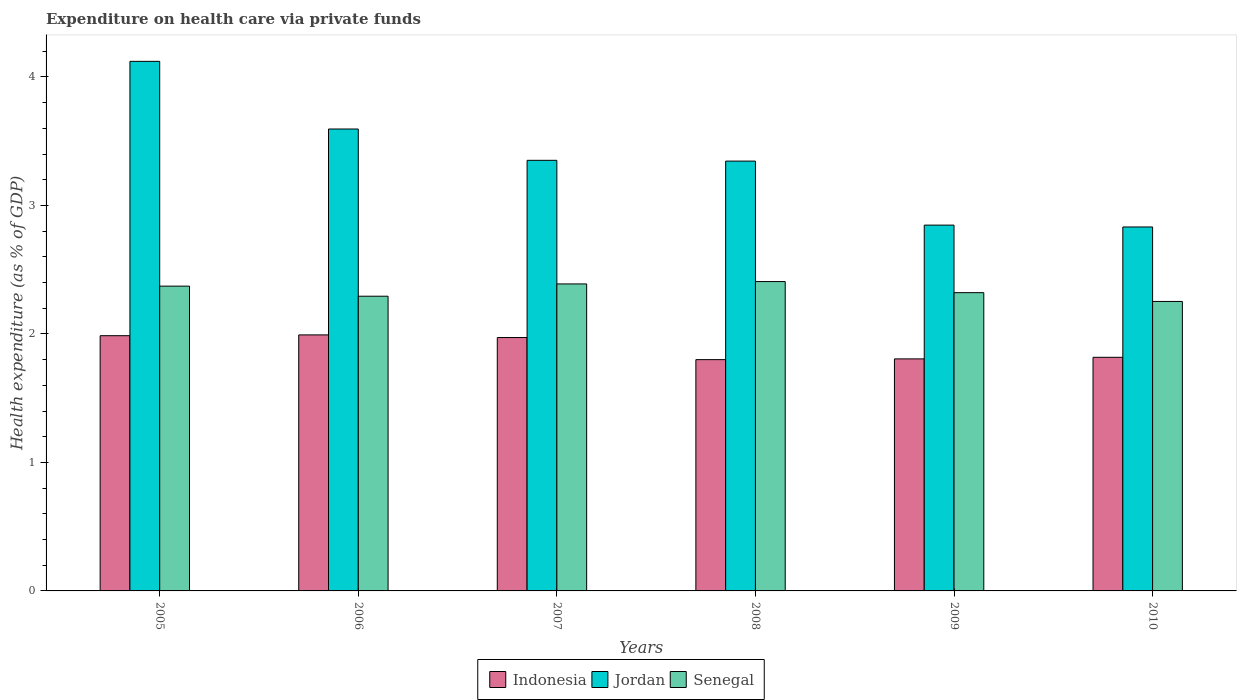Are the number of bars per tick equal to the number of legend labels?
Provide a succinct answer. Yes. Are the number of bars on each tick of the X-axis equal?
Give a very brief answer. Yes. What is the label of the 3rd group of bars from the left?
Your answer should be compact. 2007. What is the expenditure made on health care in Indonesia in 2010?
Offer a terse response. 1.82. Across all years, what is the maximum expenditure made on health care in Indonesia?
Make the answer very short. 1.99. Across all years, what is the minimum expenditure made on health care in Senegal?
Give a very brief answer. 2.25. What is the total expenditure made on health care in Indonesia in the graph?
Your answer should be very brief. 11.38. What is the difference between the expenditure made on health care in Jordan in 2008 and that in 2009?
Provide a short and direct response. 0.5. What is the difference between the expenditure made on health care in Jordan in 2007 and the expenditure made on health care in Indonesia in 2010?
Give a very brief answer. 1.53. What is the average expenditure made on health care in Senegal per year?
Provide a short and direct response. 2.34. In the year 2006, what is the difference between the expenditure made on health care in Senegal and expenditure made on health care in Jordan?
Your answer should be compact. -1.3. In how many years, is the expenditure made on health care in Senegal greater than 1.8 %?
Provide a succinct answer. 6. What is the ratio of the expenditure made on health care in Jordan in 2005 to that in 2009?
Your response must be concise. 1.45. Is the expenditure made on health care in Senegal in 2006 less than that in 2009?
Provide a succinct answer. Yes. What is the difference between the highest and the second highest expenditure made on health care in Jordan?
Offer a very short reply. 0.53. What is the difference between the highest and the lowest expenditure made on health care in Indonesia?
Offer a very short reply. 0.19. In how many years, is the expenditure made on health care in Senegal greater than the average expenditure made on health care in Senegal taken over all years?
Provide a succinct answer. 3. What does the 2nd bar from the left in 2006 represents?
Keep it short and to the point. Jordan. What does the 3rd bar from the right in 2005 represents?
Provide a short and direct response. Indonesia. Is it the case that in every year, the sum of the expenditure made on health care in Indonesia and expenditure made on health care in Senegal is greater than the expenditure made on health care in Jordan?
Give a very brief answer. Yes. How many bars are there?
Provide a succinct answer. 18. Are the values on the major ticks of Y-axis written in scientific E-notation?
Make the answer very short. No. Does the graph contain any zero values?
Provide a succinct answer. No. Where does the legend appear in the graph?
Make the answer very short. Bottom center. How many legend labels are there?
Your answer should be compact. 3. What is the title of the graph?
Provide a short and direct response. Expenditure on health care via private funds. What is the label or title of the Y-axis?
Provide a succinct answer. Health expenditure (as % of GDP). What is the Health expenditure (as % of GDP) in Indonesia in 2005?
Provide a short and direct response. 1.99. What is the Health expenditure (as % of GDP) of Jordan in 2005?
Provide a short and direct response. 4.12. What is the Health expenditure (as % of GDP) in Senegal in 2005?
Provide a short and direct response. 2.37. What is the Health expenditure (as % of GDP) in Indonesia in 2006?
Your answer should be compact. 1.99. What is the Health expenditure (as % of GDP) of Jordan in 2006?
Give a very brief answer. 3.6. What is the Health expenditure (as % of GDP) in Senegal in 2006?
Keep it short and to the point. 2.29. What is the Health expenditure (as % of GDP) of Indonesia in 2007?
Your response must be concise. 1.97. What is the Health expenditure (as % of GDP) in Jordan in 2007?
Offer a terse response. 3.35. What is the Health expenditure (as % of GDP) in Senegal in 2007?
Your answer should be compact. 2.39. What is the Health expenditure (as % of GDP) in Indonesia in 2008?
Ensure brevity in your answer.  1.8. What is the Health expenditure (as % of GDP) of Jordan in 2008?
Provide a short and direct response. 3.35. What is the Health expenditure (as % of GDP) of Senegal in 2008?
Your response must be concise. 2.41. What is the Health expenditure (as % of GDP) in Indonesia in 2009?
Offer a very short reply. 1.81. What is the Health expenditure (as % of GDP) of Jordan in 2009?
Ensure brevity in your answer.  2.85. What is the Health expenditure (as % of GDP) in Senegal in 2009?
Make the answer very short. 2.32. What is the Health expenditure (as % of GDP) of Indonesia in 2010?
Provide a short and direct response. 1.82. What is the Health expenditure (as % of GDP) of Jordan in 2010?
Offer a terse response. 2.83. What is the Health expenditure (as % of GDP) of Senegal in 2010?
Your answer should be compact. 2.25. Across all years, what is the maximum Health expenditure (as % of GDP) of Indonesia?
Keep it short and to the point. 1.99. Across all years, what is the maximum Health expenditure (as % of GDP) in Jordan?
Offer a terse response. 4.12. Across all years, what is the maximum Health expenditure (as % of GDP) in Senegal?
Offer a terse response. 2.41. Across all years, what is the minimum Health expenditure (as % of GDP) in Indonesia?
Give a very brief answer. 1.8. Across all years, what is the minimum Health expenditure (as % of GDP) of Jordan?
Your response must be concise. 2.83. Across all years, what is the minimum Health expenditure (as % of GDP) of Senegal?
Make the answer very short. 2.25. What is the total Health expenditure (as % of GDP) in Indonesia in the graph?
Your response must be concise. 11.38. What is the total Health expenditure (as % of GDP) of Jordan in the graph?
Offer a terse response. 20.09. What is the total Health expenditure (as % of GDP) of Senegal in the graph?
Offer a very short reply. 14.04. What is the difference between the Health expenditure (as % of GDP) in Indonesia in 2005 and that in 2006?
Make the answer very short. -0.01. What is the difference between the Health expenditure (as % of GDP) in Jordan in 2005 and that in 2006?
Ensure brevity in your answer.  0.53. What is the difference between the Health expenditure (as % of GDP) of Senegal in 2005 and that in 2006?
Make the answer very short. 0.08. What is the difference between the Health expenditure (as % of GDP) in Indonesia in 2005 and that in 2007?
Give a very brief answer. 0.01. What is the difference between the Health expenditure (as % of GDP) of Jordan in 2005 and that in 2007?
Your response must be concise. 0.77. What is the difference between the Health expenditure (as % of GDP) in Senegal in 2005 and that in 2007?
Give a very brief answer. -0.02. What is the difference between the Health expenditure (as % of GDP) of Indonesia in 2005 and that in 2008?
Your response must be concise. 0.19. What is the difference between the Health expenditure (as % of GDP) in Jordan in 2005 and that in 2008?
Make the answer very short. 0.78. What is the difference between the Health expenditure (as % of GDP) of Senegal in 2005 and that in 2008?
Ensure brevity in your answer.  -0.04. What is the difference between the Health expenditure (as % of GDP) of Indonesia in 2005 and that in 2009?
Provide a short and direct response. 0.18. What is the difference between the Health expenditure (as % of GDP) in Jordan in 2005 and that in 2009?
Your answer should be very brief. 1.27. What is the difference between the Health expenditure (as % of GDP) in Senegal in 2005 and that in 2009?
Offer a very short reply. 0.05. What is the difference between the Health expenditure (as % of GDP) of Indonesia in 2005 and that in 2010?
Give a very brief answer. 0.17. What is the difference between the Health expenditure (as % of GDP) in Jordan in 2005 and that in 2010?
Your answer should be very brief. 1.29. What is the difference between the Health expenditure (as % of GDP) in Senegal in 2005 and that in 2010?
Offer a terse response. 0.12. What is the difference between the Health expenditure (as % of GDP) of Indonesia in 2006 and that in 2007?
Keep it short and to the point. 0.02. What is the difference between the Health expenditure (as % of GDP) of Jordan in 2006 and that in 2007?
Offer a terse response. 0.24. What is the difference between the Health expenditure (as % of GDP) in Senegal in 2006 and that in 2007?
Provide a short and direct response. -0.1. What is the difference between the Health expenditure (as % of GDP) in Indonesia in 2006 and that in 2008?
Keep it short and to the point. 0.19. What is the difference between the Health expenditure (as % of GDP) of Jordan in 2006 and that in 2008?
Your answer should be very brief. 0.25. What is the difference between the Health expenditure (as % of GDP) of Senegal in 2006 and that in 2008?
Make the answer very short. -0.11. What is the difference between the Health expenditure (as % of GDP) in Indonesia in 2006 and that in 2009?
Provide a short and direct response. 0.19. What is the difference between the Health expenditure (as % of GDP) of Jordan in 2006 and that in 2009?
Make the answer very short. 0.75. What is the difference between the Health expenditure (as % of GDP) of Senegal in 2006 and that in 2009?
Your answer should be compact. -0.03. What is the difference between the Health expenditure (as % of GDP) in Indonesia in 2006 and that in 2010?
Make the answer very short. 0.17. What is the difference between the Health expenditure (as % of GDP) in Jordan in 2006 and that in 2010?
Your answer should be very brief. 0.76. What is the difference between the Health expenditure (as % of GDP) of Senegal in 2006 and that in 2010?
Your answer should be very brief. 0.04. What is the difference between the Health expenditure (as % of GDP) of Indonesia in 2007 and that in 2008?
Your response must be concise. 0.17. What is the difference between the Health expenditure (as % of GDP) in Jordan in 2007 and that in 2008?
Make the answer very short. 0.01. What is the difference between the Health expenditure (as % of GDP) of Senegal in 2007 and that in 2008?
Make the answer very short. -0.02. What is the difference between the Health expenditure (as % of GDP) of Indonesia in 2007 and that in 2009?
Provide a short and direct response. 0.17. What is the difference between the Health expenditure (as % of GDP) in Jordan in 2007 and that in 2009?
Your answer should be very brief. 0.5. What is the difference between the Health expenditure (as % of GDP) in Senegal in 2007 and that in 2009?
Your answer should be compact. 0.07. What is the difference between the Health expenditure (as % of GDP) in Indonesia in 2007 and that in 2010?
Your answer should be very brief. 0.15. What is the difference between the Health expenditure (as % of GDP) of Jordan in 2007 and that in 2010?
Offer a terse response. 0.52. What is the difference between the Health expenditure (as % of GDP) of Senegal in 2007 and that in 2010?
Offer a terse response. 0.14. What is the difference between the Health expenditure (as % of GDP) of Indonesia in 2008 and that in 2009?
Offer a terse response. -0.01. What is the difference between the Health expenditure (as % of GDP) in Jordan in 2008 and that in 2009?
Your answer should be very brief. 0.5. What is the difference between the Health expenditure (as % of GDP) in Senegal in 2008 and that in 2009?
Ensure brevity in your answer.  0.09. What is the difference between the Health expenditure (as % of GDP) in Indonesia in 2008 and that in 2010?
Your response must be concise. -0.02. What is the difference between the Health expenditure (as % of GDP) in Jordan in 2008 and that in 2010?
Your answer should be compact. 0.51. What is the difference between the Health expenditure (as % of GDP) of Senegal in 2008 and that in 2010?
Offer a terse response. 0.15. What is the difference between the Health expenditure (as % of GDP) of Indonesia in 2009 and that in 2010?
Keep it short and to the point. -0.01. What is the difference between the Health expenditure (as % of GDP) in Jordan in 2009 and that in 2010?
Make the answer very short. 0.01. What is the difference between the Health expenditure (as % of GDP) in Senegal in 2009 and that in 2010?
Your answer should be compact. 0.07. What is the difference between the Health expenditure (as % of GDP) in Indonesia in 2005 and the Health expenditure (as % of GDP) in Jordan in 2006?
Your answer should be compact. -1.61. What is the difference between the Health expenditure (as % of GDP) of Indonesia in 2005 and the Health expenditure (as % of GDP) of Senegal in 2006?
Your answer should be compact. -0.31. What is the difference between the Health expenditure (as % of GDP) in Jordan in 2005 and the Health expenditure (as % of GDP) in Senegal in 2006?
Offer a very short reply. 1.83. What is the difference between the Health expenditure (as % of GDP) of Indonesia in 2005 and the Health expenditure (as % of GDP) of Jordan in 2007?
Keep it short and to the point. -1.36. What is the difference between the Health expenditure (as % of GDP) of Indonesia in 2005 and the Health expenditure (as % of GDP) of Senegal in 2007?
Your answer should be compact. -0.4. What is the difference between the Health expenditure (as % of GDP) in Jordan in 2005 and the Health expenditure (as % of GDP) in Senegal in 2007?
Provide a short and direct response. 1.73. What is the difference between the Health expenditure (as % of GDP) in Indonesia in 2005 and the Health expenditure (as % of GDP) in Jordan in 2008?
Give a very brief answer. -1.36. What is the difference between the Health expenditure (as % of GDP) in Indonesia in 2005 and the Health expenditure (as % of GDP) in Senegal in 2008?
Provide a succinct answer. -0.42. What is the difference between the Health expenditure (as % of GDP) of Jordan in 2005 and the Health expenditure (as % of GDP) of Senegal in 2008?
Ensure brevity in your answer.  1.71. What is the difference between the Health expenditure (as % of GDP) of Indonesia in 2005 and the Health expenditure (as % of GDP) of Jordan in 2009?
Offer a terse response. -0.86. What is the difference between the Health expenditure (as % of GDP) of Indonesia in 2005 and the Health expenditure (as % of GDP) of Senegal in 2009?
Keep it short and to the point. -0.33. What is the difference between the Health expenditure (as % of GDP) of Jordan in 2005 and the Health expenditure (as % of GDP) of Senegal in 2009?
Ensure brevity in your answer.  1.8. What is the difference between the Health expenditure (as % of GDP) of Indonesia in 2005 and the Health expenditure (as % of GDP) of Jordan in 2010?
Give a very brief answer. -0.85. What is the difference between the Health expenditure (as % of GDP) of Indonesia in 2005 and the Health expenditure (as % of GDP) of Senegal in 2010?
Provide a short and direct response. -0.27. What is the difference between the Health expenditure (as % of GDP) in Jordan in 2005 and the Health expenditure (as % of GDP) in Senegal in 2010?
Give a very brief answer. 1.87. What is the difference between the Health expenditure (as % of GDP) of Indonesia in 2006 and the Health expenditure (as % of GDP) of Jordan in 2007?
Provide a short and direct response. -1.36. What is the difference between the Health expenditure (as % of GDP) in Indonesia in 2006 and the Health expenditure (as % of GDP) in Senegal in 2007?
Provide a short and direct response. -0.4. What is the difference between the Health expenditure (as % of GDP) of Jordan in 2006 and the Health expenditure (as % of GDP) of Senegal in 2007?
Provide a short and direct response. 1.21. What is the difference between the Health expenditure (as % of GDP) of Indonesia in 2006 and the Health expenditure (as % of GDP) of Jordan in 2008?
Your response must be concise. -1.35. What is the difference between the Health expenditure (as % of GDP) of Indonesia in 2006 and the Health expenditure (as % of GDP) of Senegal in 2008?
Provide a succinct answer. -0.42. What is the difference between the Health expenditure (as % of GDP) in Jordan in 2006 and the Health expenditure (as % of GDP) in Senegal in 2008?
Your answer should be very brief. 1.19. What is the difference between the Health expenditure (as % of GDP) in Indonesia in 2006 and the Health expenditure (as % of GDP) in Jordan in 2009?
Your response must be concise. -0.85. What is the difference between the Health expenditure (as % of GDP) of Indonesia in 2006 and the Health expenditure (as % of GDP) of Senegal in 2009?
Keep it short and to the point. -0.33. What is the difference between the Health expenditure (as % of GDP) in Jordan in 2006 and the Health expenditure (as % of GDP) in Senegal in 2009?
Offer a terse response. 1.27. What is the difference between the Health expenditure (as % of GDP) of Indonesia in 2006 and the Health expenditure (as % of GDP) of Jordan in 2010?
Offer a terse response. -0.84. What is the difference between the Health expenditure (as % of GDP) of Indonesia in 2006 and the Health expenditure (as % of GDP) of Senegal in 2010?
Provide a succinct answer. -0.26. What is the difference between the Health expenditure (as % of GDP) in Jordan in 2006 and the Health expenditure (as % of GDP) in Senegal in 2010?
Give a very brief answer. 1.34. What is the difference between the Health expenditure (as % of GDP) in Indonesia in 2007 and the Health expenditure (as % of GDP) in Jordan in 2008?
Offer a terse response. -1.37. What is the difference between the Health expenditure (as % of GDP) of Indonesia in 2007 and the Health expenditure (as % of GDP) of Senegal in 2008?
Make the answer very short. -0.44. What is the difference between the Health expenditure (as % of GDP) in Jordan in 2007 and the Health expenditure (as % of GDP) in Senegal in 2008?
Offer a very short reply. 0.94. What is the difference between the Health expenditure (as % of GDP) of Indonesia in 2007 and the Health expenditure (as % of GDP) of Jordan in 2009?
Your answer should be compact. -0.88. What is the difference between the Health expenditure (as % of GDP) of Indonesia in 2007 and the Health expenditure (as % of GDP) of Senegal in 2009?
Provide a short and direct response. -0.35. What is the difference between the Health expenditure (as % of GDP) in Jordan in 2007 and the Health expenditure (as % of GDP) in Senegal in 2009?
Provide a short and direct response. 1.03. What is the difference between the Health expenditure (as % of GDP) of Indonesia in 2007 and the Health expenditure (as % of GDP) of Jordan in 2010?
Offer a very short reply. -0.86. What is the difference between the Health expenditure (as % of GDP) in Indonesia in 2007 and the Health expenditure (as % of GDP) in Senegal in 2010?
Your response must be concise. -0.28. What is the difference between the Health expenditure (as % of GDP) of Jordan in 2007 and the Health expenditure (as % of GDP) of Senegal in 2010?
Make the answer very short. 1.1. What is the difference between the Health expenditure (as % of GDP) in Indonesia in 2008 and the Health expenditure (as % of GDP) in Jordan in 2009?
Ensure brevity in your answer.  -1.05. What is the difference between the Health expenditure (as % of GDP) in Indonesia in 2008 and the Health expenditure (as % of GDP) in Senegal in 2009?
Your answer should be compact. -0.52. What is the difference between the Health expenditure (as % of GDP) in Jordan in 2008 and the Health expenditure (as % of GDP) in Senegal in 2009?
Give a very brief answer. 1.02. What is the difference between the Health expenditure (as % of GDP) in Indonesia in 2008 and the Health expenditure (as % of GDP) in Jordan in 2010?
Your response must be concise. -1.03. What is the difference between the Health expenditure (as % of GDP) in Indonesia in 2008 and the Health expenditure (as % of GDP) in Senegal in 2010?
Keep it short and to the point. -0.45. What is the difference between the Health expenditure (as % of GDP) of Jordan in 2008 and the Health expenditure (as % of GDP) of Senegal in 2010?
Offer a very short reply. 1.09. What is the difference between the Health expenditure (as % of GDP) in Indonesia in 2009 and the Health expenditure (as % of GDP) in Jordan in 2010?
Offer a terse response. -1.03. What is the difference between the Health expenditure (as % of GDP) in Indonesia in 2009 and the Health expenditure (as % of GDP) in Senegal in 2010?
Make the answer very short. -0.45. What is the difference between the Health expenditure (as % of GDP) of Jordan in 2009 and the Health expenditure (as % of GDP) of Senegal in 2010?
Provide a short and direct response. 0.59. What is the average Health expenditure (as % of GDP) of Indonesia per year?
Your answer should be very brief. 1.9. What is the average Health expenditure (as % of GDP) in Jordan per year?
Your response must be concise. 3.35. What is the average Health expenditure (as % of GDP) of Senegal per year?
Provide a short and direct response. 2.34. In the year 2005, what is the difference between the Health expenditure (as % of GDP) in Indonesia and Health expenditure (as % of GDP) in Jordan?
Provide a succinct answer. -2.14. In the year 2005, what is the difference between the Health expenditure (as % of GDP) of Indonesia and Health expenditure (as % of GDP) of Senegal?
Offer a very short reply. -0.39. In the year 2005, what is the difference between the Health expenditure (as % of GDP) of Jordan and Health expenditure (as % of GDP) of Senegal?
Your response must be concise. 1.75. In the year 2006, what is the difference between the Health expenditure (as % of GDP) of Indonesia and Health expenditure (as % of GDP) of Jordan?
Provide a succinct answer. -1.6. In the year 2006, what is the difference between the Health expenditure (as % of GDP) of Indonesia and Health expenditure (as % of GDP) of Senegal?
Your answer should be compact. -0.3. In the year 2006, what is the difference between the Health expenditure (as % of GDP) of Jordan and Health expenditure (as % of GDP) of Senegal?
Give a very brief answer. 1.3. In the year 2007, what is the difference between the Health expenditure (as % of GDP) in Indonesia and Health expenditure (as % of GDP) in Jordan?
Keep it short and to the point. -1.38. In the year 2007, what is the difference between the Health expenditure (as % of GDP) of Indonesia and Health expenditure (as % of GDP) of Senegal?
Offer a terse response. -0.42. In the year 2008, what is the difference between the Health expenditure (as % of GDP) in Indonesia and Health expenditure (as % of GDP) in Jordan?
Give a very brief answer. -1.55. In the year 2008, what is the difference between the Health expenditure (as % of GDP) of Indonesia and Health expenditure (as % of GDP) of Senegal?
Give a very brief answer. -0.61. In the year 2008, what is the difference between the Health expenditure (as % of GDP) in Jordan and Health expenditure (as % of GDP) in Senegal?
Give a very brief answer. 0.94. In the year 2009, what is the difference between the Health expenditure (as % of GDP) in Indonesia and Health expenditure (as % of GDP) in Jordan?
Make the answer very short. -1.04. In the year 2009, what is the difference between the Health expenditure (as % of GDP) in Indonesia and Health expenditure (as % of GDP) in Senegal?
Offer a very short reply. -0.52. In the year 2009, what is the difference between the Health expenditure (as % of GDP) of Jordan and Health expenditure (as % of GDP) of Senegal?
Your answer should be very brief. 0.53. In the year 2010, what is the difference between the Health expenditure (as % of GDP) of Indonesia and Health expenditure (as % of GDP) of Jordan?
Offer a very short reply. -1.01. In the year 2010, what is the difference between the Health expenditure (as % of GDP) in Indonesia and Health expenditure (as % of GDP) in Senegal?
Your answer should be very brief. -0.43. In the year 2010, what is the difference between the Health expenditure (as % of GDP) in Jordan and Health expenditure (as % of GDP) in Senegal?
Keep it short and to the point. 0.58. What is the ratio of the Health expenditure (as % of GDP) of Jordan in 2005 to that in 2006?
Ensure brevity in your answer.  1.15. What is the ratio of the Health expenditure (as % of GDP) of Senegal in 2005 to that in 2006?
Make the answer very short. 1.03. What is the ratio of the Health expenditure (as % of GDP) in Indonesia in 2005 to that in 2007?
Your response must be concise. 1.01. What is the ratio of the Health expenditure (as % of GDP) in Jordan in 2005 to that in 2007?
Keep it short and to the point. 1.23. What is the ratio of the Health expenditure (as % of GDP) in Indonesia in 2005 to that in 2008?
Provide a succinct answer. 1.1. What is the ratio of the Health expenditure (as % of GDP) in Jordan in 2005 to that in 2008?
Provide a succinct answer. 1.23. What is the ratio of the Health expenditure (as % of GDP) of Indonesia in 2005 to that in 2009?
Ensure brevity in your answer.  1.1. What is the ratio of the Health expenditure (as % of GDP) of Jordan in 2005 to that in 2009?
Your answer should be compact. 1.45. What is the ratio of the Health expenditure (as % of GDP) in Senegal in 2005 to that in 2009?
Make the answer very short. 1.02. What is the ratio of the Health expenditure (as % of GDP) in Indonesia in 2005 to that in 2010?
Offer a terse response. 1.09. What is the ratio of the Health expenditure (as % of GDP) of Jordan in 2005 to that in 2010?
Give a very brief answer. 1.46. What is the ratio of the Health expenditure (as % of GDP) of Senegal in 2005 to that in 2010?
Your answer should be compact. 1.05. What is the ratio of the Health expenditure (as % of GDP) in Indonesia in 2006 to that in 2007?
Your response must be concise. 1.01. What is the ratio of the Health expenditure (as % of GDP) of Jordan in 2006 to that in 2007?
Your answer should be compact. 1.07. What is the ratio of the Health expenditure (as % of GDP) of Indonesia in 2006 to that in 2008?
Give a very brief answer. 1.11. What is the ratio of the Health expenditure (as % of GDP) in Jordan in 2006 to that in 2008?
Offer a very short reply. 1.07. What is the ratio of the Health expenditure (as % of GDP) of Senegal in 2006 to that in 2008?
Make the answer very short. 0.95. What is the ratio of the Health expenditure (as % of GDP) in Indonesia in 2006 to that in 2009?
Keep it short and to the point. 1.1. What is the ratio of the Health expenditure (as % of GDP) of Jordan in 2006 to that in 2009?
Your answer should be very brief. 1.26. What is the ratio of the Health expenditure (as % of GDP) in Senegal in 2006 to that in 2009?
Your response must be concise. 0.99. What is the ratio of the Health expenditure (as % of GDP) of Indonesia in 2006 to that in 2010?
Provide a succinct answer. 1.1. What is the ratio of the Health expenditure (as % of GDP) in Jordan in 2006 to that in 2010?
Ensure brevity in your answer.  1.27. What is the ratio of the Health expenditure (as % of GDP) of Senegal in 2006 to that in 2010?
Your response must be concise. 1.02. What is the ratio of the Health expenditure (as % of GDP) in Indonesia in 2007 to that in 2008?
Your answer should be very brief. 1.1. What is the ratio of the Health expenditure (as % of GDP) of Senegal in 2007 to that in 2008?
Your response must be concise. 0.99. What is the ratio of the Health expenditure (as % of GDP) of Indonesia in 2007 to that in 2009?
Make the answer very short. 1.09. What is the ratio of the Health expenditure (as % of GDP) of Jordan in 2007 to that in 2009?
Provide a succinct answer. 1.18. What is the ratio of the Health expenditure (as % of GDP) of Senegal in 2007 to that in 2009?
Provide a succinct answer. 1.03. What is the ratio of the Health expenditure (as % of GDP) of Indonesia in 2007 to that in 2010?
Make the answer very short. 1.08. What is the ratio of the Health expenditure (as % of GDP) of Jordan in 2007 to that in 2010?
Offer a very short reply. 1.18. What is the ratio of the Health expenditure (as % of GDP) in Senegal in 2007 to that in 2010?
Provide a short and direct response. 1.06. What is the ratio of the Health expenditure (as % of GDP) of Jordan in 2008 to that in 2009?
Your answer should be compact. 1.18. What is the ratio of the Health expenditure (as % of GDP) of Senegal in 2008 to that in 2009?
Your answer should be very brief. 1.04. What is the ratio of the Health expenditure (as % of GDP) of Indonesia in 2008 to that in 2010?
Provide a short and direct response. 0.99. What is the ratio of the Health expenditure (as % of GDP) in Jordan in 2008 to that in 2010?
Your answer should be very brief. 1.18. What is the ratio of the Health expenditure (as % of GDP) in Senegal in 2008 to that in 2010?
Ensure brevity in your answer.  1.07. What is the ratio of the Health expenditure (as % of GDP) in Senegal in 2009 to that in 2010?
Keep it short and to the point. 1.03. What is the difference between the highest and the second highest Health expenditure (as % of GDP) in Indonesia?
Your answer should be compact. 0.01. What is the difference between the highest and the second highest Health expenditure (as % of GDP) in Jordan?
Your response must be concise. 0.53. What is the difference between the highest and the second highest Health expenditure (as % of GDP) of Senegal?
Keep it short and to the point. 0.02. What is the difference between the highest and the lowest Health expenditure (as % of GDP) of Indonesia?
Provide a succinct answer. 0.19. What is the difference between the highest and the lowest Health expenditure (as % of GDP) of Jordan?
Keep it short and to the point. 1.29. What is the difference between the highest and the lowest Health expenditure (as % of GDP) in Senegal?
Your answer should be very brief. 0.15. 